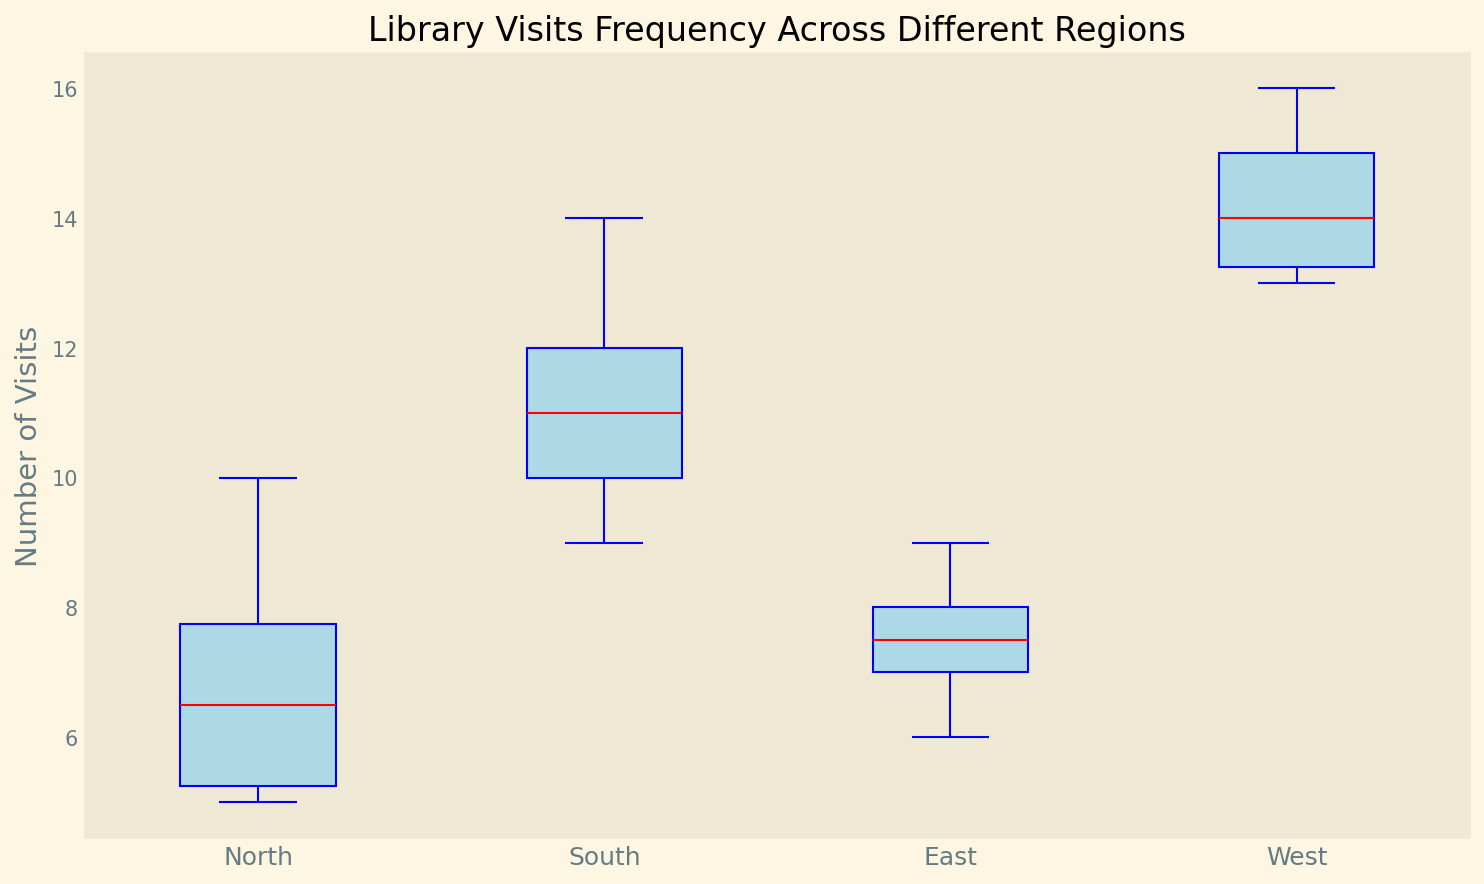How many distinct regions are represented in the figure? The box plot labels indicate four distinct regions: North, South, East, and West.
Answer: 4 Which region has the highest median number of library visits? In the box plot, the median is represented by the red line within each box. By comparing the red lines, we see the West region's median is the highest.
Answer: West What is the range of library visits in the South region? The range is calculated by subtracting the lowest value (whisker at the bottom) from the highest value (whisker at the top) in the South's box plot. The lowest is 9 and the highest is 14, so the range is 14 - 9.
Answer: 5 Which region has the smallest interquartile range (IQR) of library visits? The IQR is represented by the height of the box itself. The North region has the smallest box height, indicating the smallest IQR.
Answer: North Compare the maximum number of visits in the North and East regions. Which one is higher and by how much? The maximum number of visits is represented by the top whisker. For North, it's 10, and for East, it's 9. Thus, North's maximum is higher by 10 - 9.
Answer: North by 1 Which region contains outliers and how are they visually represented? Outliers are represented by ovals or circles outside the whiskers. The South region has green circles at the top indicating outliers.
Answer: South What color is used for the boxes in the box plot? The boxes in the box plot are filled with light blue color.
Answer: Light blue By visually estimating, what can be said about the variability in library visits in the West region compared to the East region? The variability within a region is often shown by the length of the whiskers and the height of the box. West has taller whiskers and higher box height compared to East, indicating greater variability.
Answer: Greater in West What is the lower quartile (Q1) of library visits in the North region? The lower quartile (Q1) is represented by the bottom of the box in a box plot. For North, Q1 appears to be at 5.
Answer: 5 